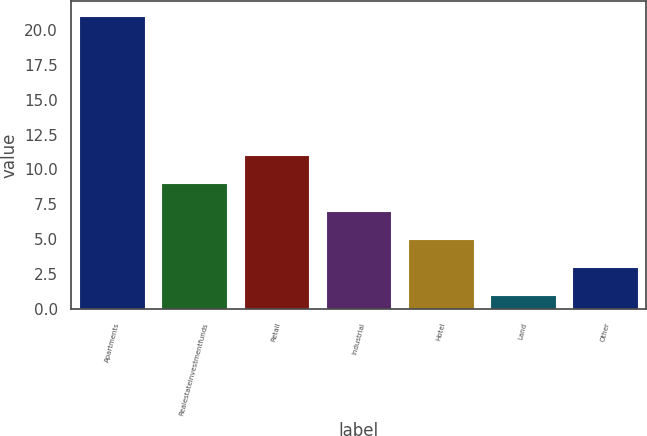Convert chart to OTSL. <chart><loc_0><loc_0><loc_500><loc_500><bar_chart><fcel>Apartments<fcel>Realestateinvestmentfunds<fcel>Retail<fcel>Industrial<fcel>Hotel<fcel>Land<fcel>Other<nl><fcel>21<fcel>9<fcel>11<fcel>7<fcel>5<fcel>1<fcel>3<nl></chart> 